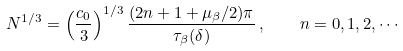<formula> <loc_0><loc_0><loc_500><loc_500>N ^ { 1 / 3 } = \left ( \frac { c _ { 0 } } { 3 } \right ) ^ { 1 / 3 } \frac { ( 2 n + 1 + \mu _ { \beta } / 2 ) \pi } { \tau _ { \beta } ( \delta ) } \, , \quad n = 0 , 1 , 2 , \cdots</formula> 